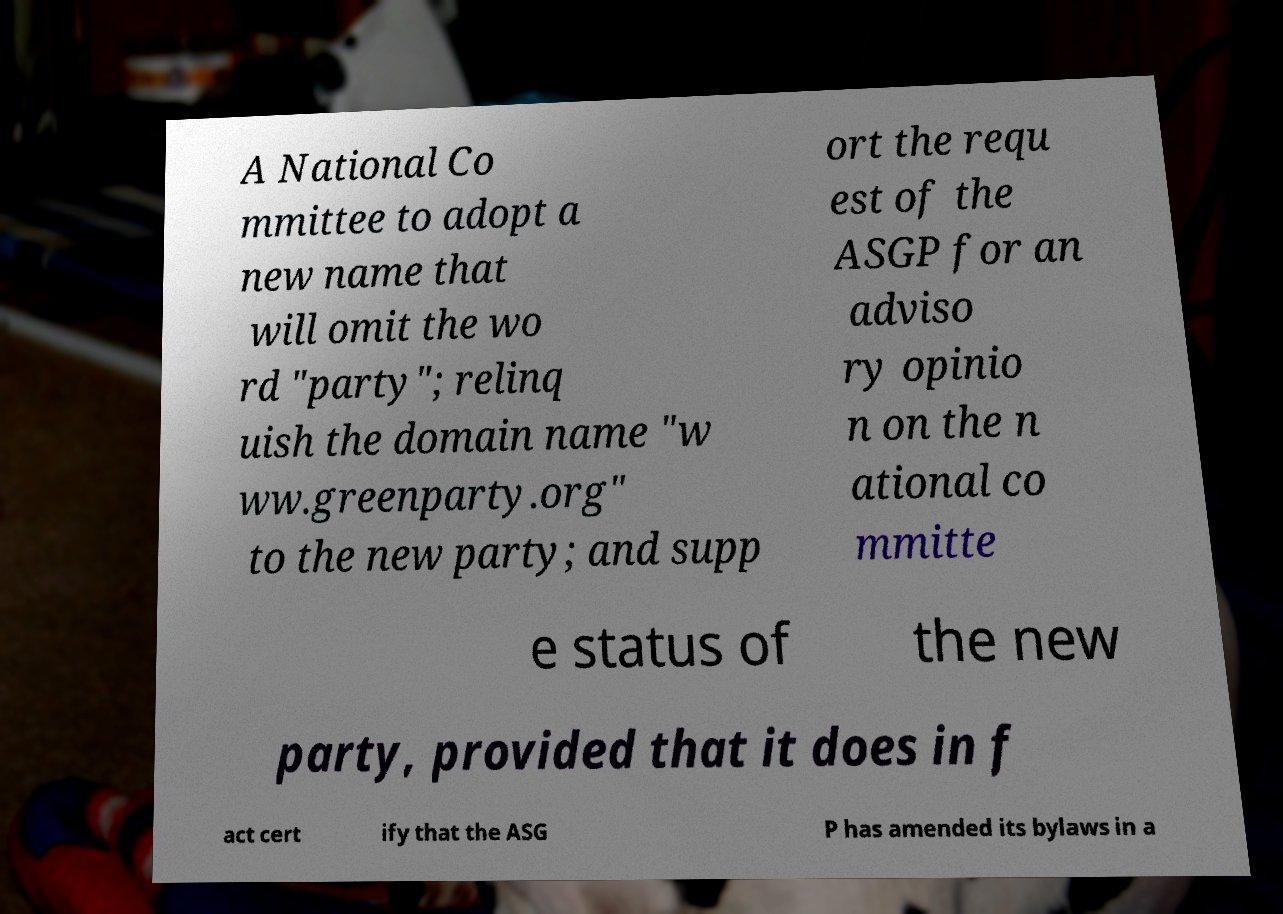Can you read and provide the text displayed in the image?This photo seems to have some interesting text. Can you extract and type it out for me? A National Co mmittee to adopt a new name that will omit the wo rd "party"; relinq uish the domain name "w ww.greenparty.org" to the new party; and supp ort the requ est of the ASGP for an adviso ry opinio n on the n ational co mmitte e status of the new party, provided that it does in f act cert ify that the ASG P has amended its bylaws in a 